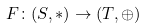Convert formula to latex. <formula><loc_0><loc_0><loc_500><loc_500>F \colon ( S , * ) \rightarrow ( T , \oplus )</formula> 